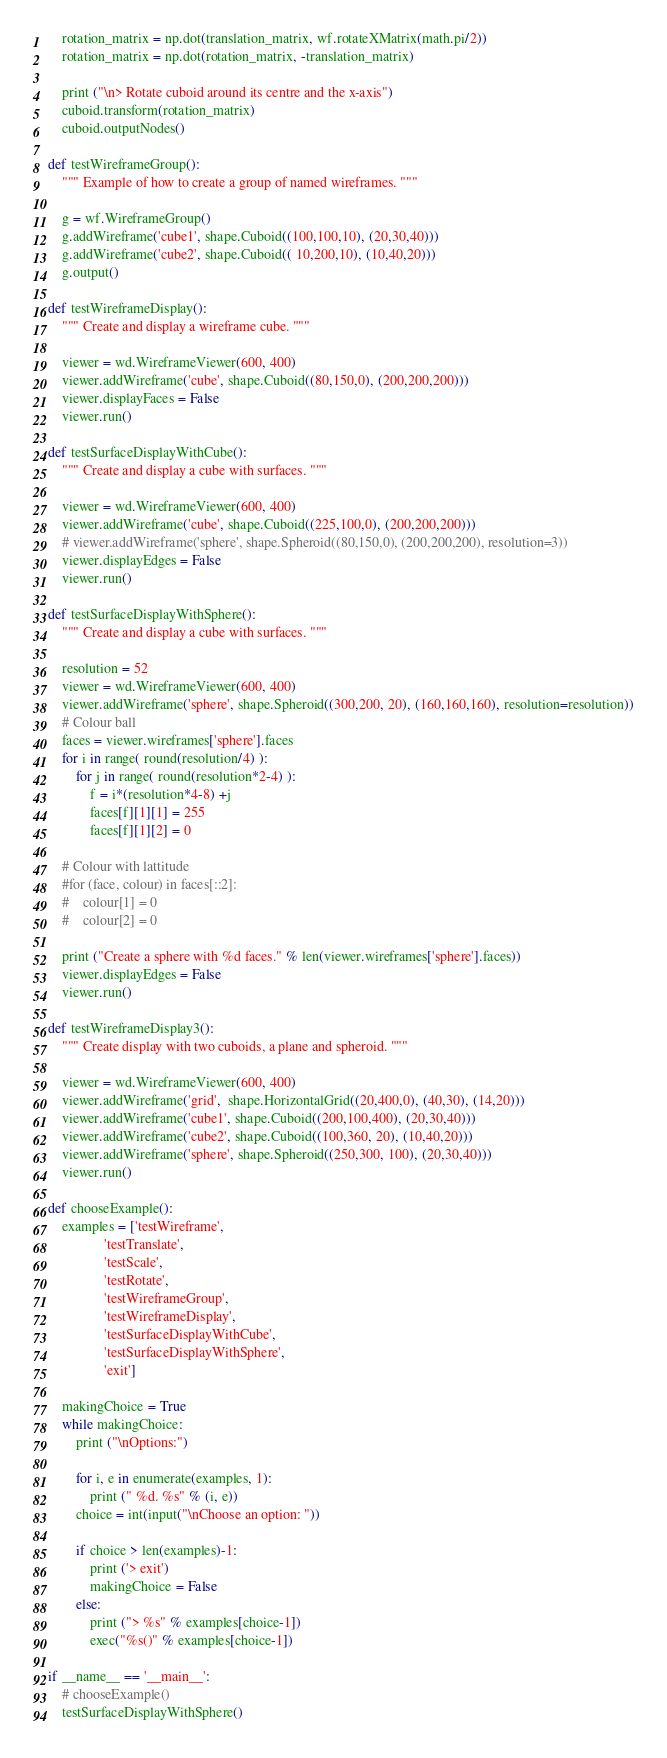Convert code to text. <code><loc_0><loc_0><loc_500><loc_500><_Python_>    rotation_matrix = np.dot(translation_matrix, wf.rotateXMatrix(math.pi/2))
    rotation_matrix = np.dot(rotation_matrix, -translation_matrix)
    
    print ("\n> Rotate cuboid around its centre and the x-axis")
    cuboid.transform(rotation_matrix)
    cuboid.outputNodes()

def testWireframeGroup():
    """ Example of how to create a group of named wireframes. """

    g = wf.WireframeGroup()
    g.addWireframe('cube1', shape.Cuboid((100,100,10), (20,30,40)))
    g.addWireframe('cube2', shape.Cuboid(( 10,200,10), (10,40,20)))        
    g.output()

def testWireframeDisplay():
    """ Create and display a wireframe cube. """
    
    viewer = wd.WireframeViewer(600, 400)
    viewer.addWireframe('cube', shape.Cuboid((80,150,0), (200,200,200)))
    viewer.displayFaces = False
    viewer.run()

def testSurfaceDisplayWithCube():
    """ Create and display a cube with surfaces. """
    
    viewer = wd.WireframeViewer(600, 400)
    viewer.addWireframe('cube', shape.Cuboid((225,100,0), (200,200,200)))
    # viewer.addWireframe('sphere', shape.Spheroid((80,150,0), (200,200,200), resolution=3))
    viewer.displayEdges = False
    viewer.run()
    
def testSurfaceDisplayWithSphere():
    """ Create and display a cube with surfaces. """
    
    resolution = 52
    viewer = wd.WireframeViewer(600, 400)
    viewer.addWireframe('sphere', shape.Spheroid((300,200, 20), (160,160,160), resolution=resolution))
    # Colour ball
    faces = viewer.wireframes['sphere'].faces
    for i in range( round(resolution/4) ):
        for j in range( round(resolution*2-4) ):
            f = i*(resolution*4-8) +j
            faces[f][1][1] = 255
            faces[f][1][2] = 0
        
    # Colour with lattitude
    #for (face, colour) in faces[::2]:
    #    colour[1] = 0
    #    colour[2] = 0
    
    print ("Create a sphere with %d faces." % len(viewer.wireframes['sphere'].faces))
    viewer.displayEdges = False
    viewer.run()
    
def testWireframeDisplay3():
    """ Create display with two cuboids, a plane and spheroid. """
    
    viewer = wd.WireframeViewer(600, 400)
    viewer.addWireframe('grid',  shape.HorizontalGrid((20,400,0), (40,30), (14,20)))
    viewer.addWireframe('cube1', shape.Cuboid((200,100,400), (20,30,40)))
    viewer.addWireframe('cube2', shape.Cuboid((100,360, 20), (10,40,20)))
    viewer.addWireframe('sphere', shape.Spheroid((250,300, 100), (20,30,40)))
    viewer.run()

def chooseExample():
    examples = ['testWireframe',
                'testTranslate',
                'testScale',
                'testRotate',
                'testWireframeGroup',
                'testWireframeDisplay',
                'testSurfaceDisplayWithCube',
                'testSurfaceDisplayWithSphere',
                'exit']
        
    makingChoice = True    
    while makingChoice:
        print ("\nOptions:")
        
        for i, e in enumerate(examples, 1):
            print (" %d. %s" % (i, e))
        choice = int(input("\nChoose an option: "))
        
        if choice > len(examples)-1:
            print ('> exit')
            makingChoice = False
        else:
            print ("> %s" % examples[choice-1])
            exec("%s()" % examples[choice-1])
    
if __name__ == '__main__':
    # chooseExample()
    testSurfaceDisplayWithSphere()
</code> 